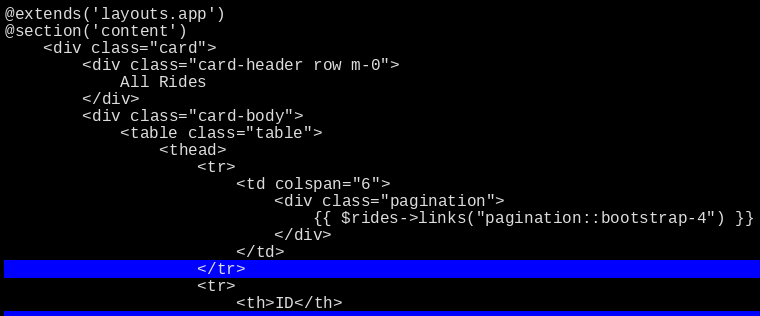Convert code to text. <code><loc_0><loc_0><loc_500><loc_500><_PHP_>@extends('layouts.app')
@section('content')
    <div class="card">
        <div class="card-header row m-0">
            All Rides
        </div>
        <div class="card-body">
            <table class="table">
                <thead>
                    <tr>
                        <td colspan="6">
                            <div class="pagination">
                                {{ $rides->links("pagination::bootstrap-4") }}
                            </div>
                        </td>
                    </tr>
                    <tr>
                        <th>ID</th></code> 